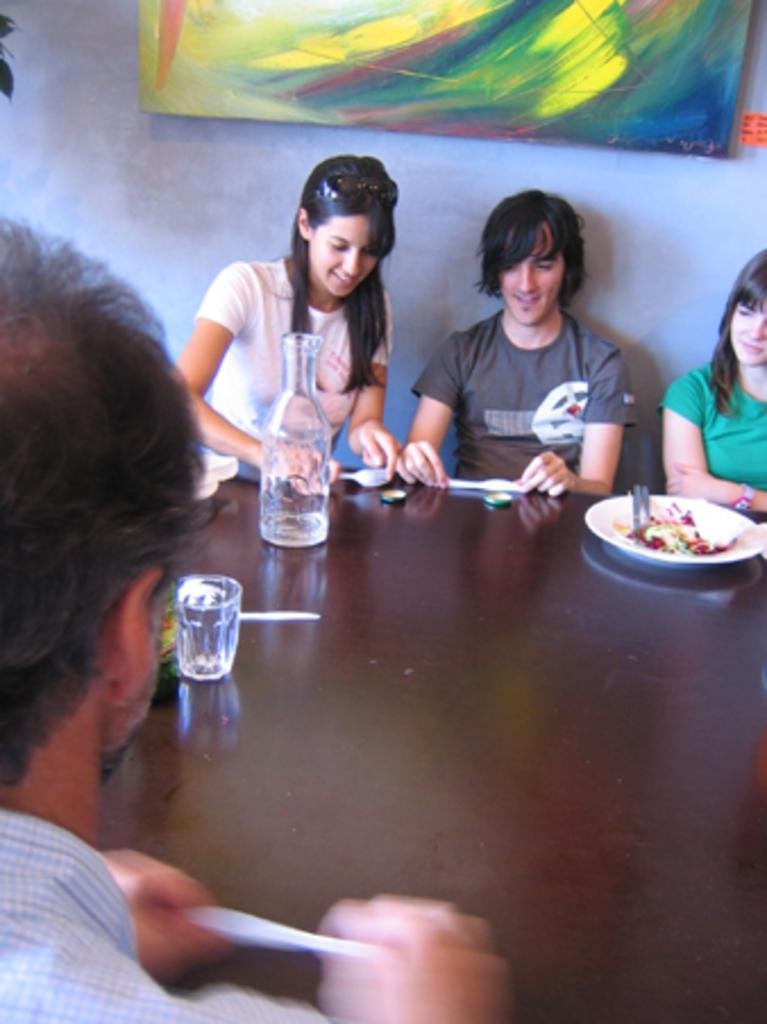How many people are sitting around the table in the image? There are persons sitting around the table in the image. What objects can be seen on the table? There is a glass, a bottle, a spoon, a plate, and a food item on the table. What is the background of the image? There is a wall in the background, and there is a painting on the wall. What type of neck accessory is the person wearing in the image? There is no person wearing a neck accessory in the image. How many cherries are on the plate in the image? There is no mention of cherries in the image; only a food item is mentioned. 